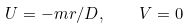<formula> <loc_0><loc_0><loc_500><loc_500>U = - m r / D , \quad V = 0</formula> 